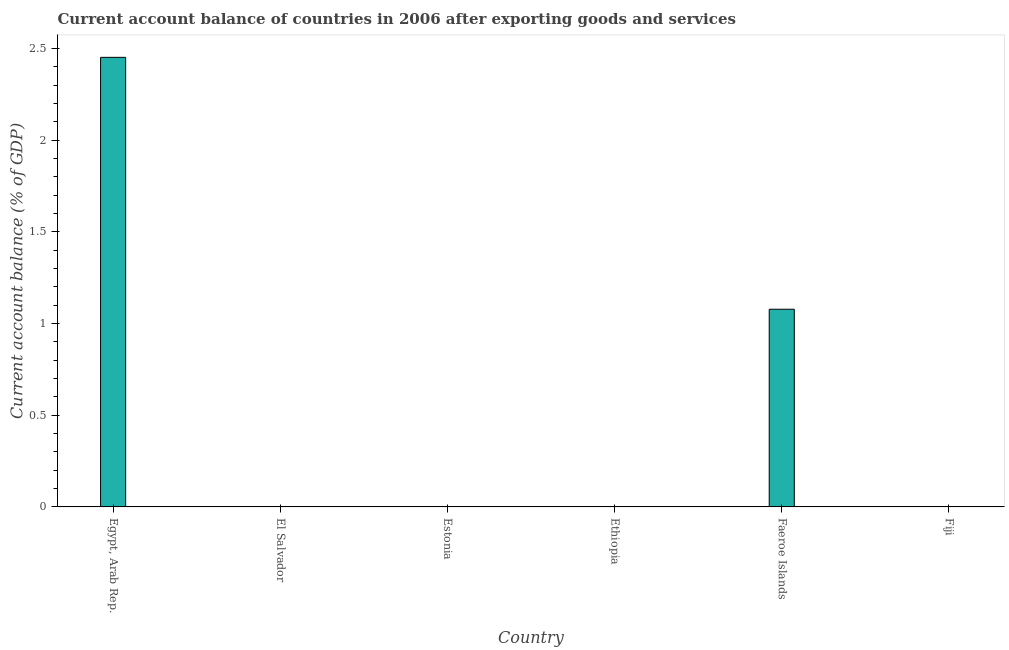Does the graph contain grids?
Ensure brevity in your answer.  No. What is the title of the graph?
Provide a succinct answer. Current account balance of countries in 2006 after exporting goods and services. What is the label or title of the Y-axis?
Offer a very short reply. Current account balance (% of GDP). What is the current account balance in Egypt, Arab Rep.?
Your answer should be very brief. 2.45. Across all countries, what is the maximum current account balance?
Your answer should be compact. 2.45. In which country was the current account balance maximum?
Ensure brevity in your answer.  Egypt, Arab Rep. What is the sum of the current account balance?
Provide a succinct answer. 3.53. What is the difference between the current account balance in Egypt, Arab Rep. and Faeroe Islands?
Provide a succinct answer. 1.37. What is the average current account balance per country?
Make the answer very short. 0.59. In how many countries, is the current account balance greater than 0.6 %?
Ensure brevity in your answer.  2. What is the difference between the highest and the lowest current account balance?
Give a very brief answer. 2.45. In how many countries, is the current account balance greater than the average current account balance taken over all countries?
Offer a terse response. 2. How many bars are there?
Your answer should be very brief. 2. How many countries are there in the graph?
Give a very brief answer. 6. Are the values on the major ticks of Y-axis written in scientific E-notation?
Provide a succinct answer. No. What is the Current account balance (% of GDP) in Egypt, Arab Rep.?
Your response must be concise. 2.45. What is the Current account balance (% of GDP) in El Salvador?
Ensure brevity in your answer.  0. What is the Current account balance (% of GDP) in Estonia?
Offer a very short reply. 0. What is the Current account balance (% of GDP) in Ethiopia?
Provide a short and direct response. 0. What is the Current account balance (% of GDP) of Faeroe Islands?
Your response must be concise. 1.08. What is the Current account balance (% of GDP) in Fiji?
Offer a very short reply. 0. What is the difference between the Current account balance (% of GDP) in Egypt, Arab Rep. and Faeroe Islands?
Ensure brevity in your answer.  1.37. What is the ratio of the Current account balance (% of GDP) in Egypt, Arab Rep. to that in Faeroe Islands?
Make the answer very short. 2.27. 